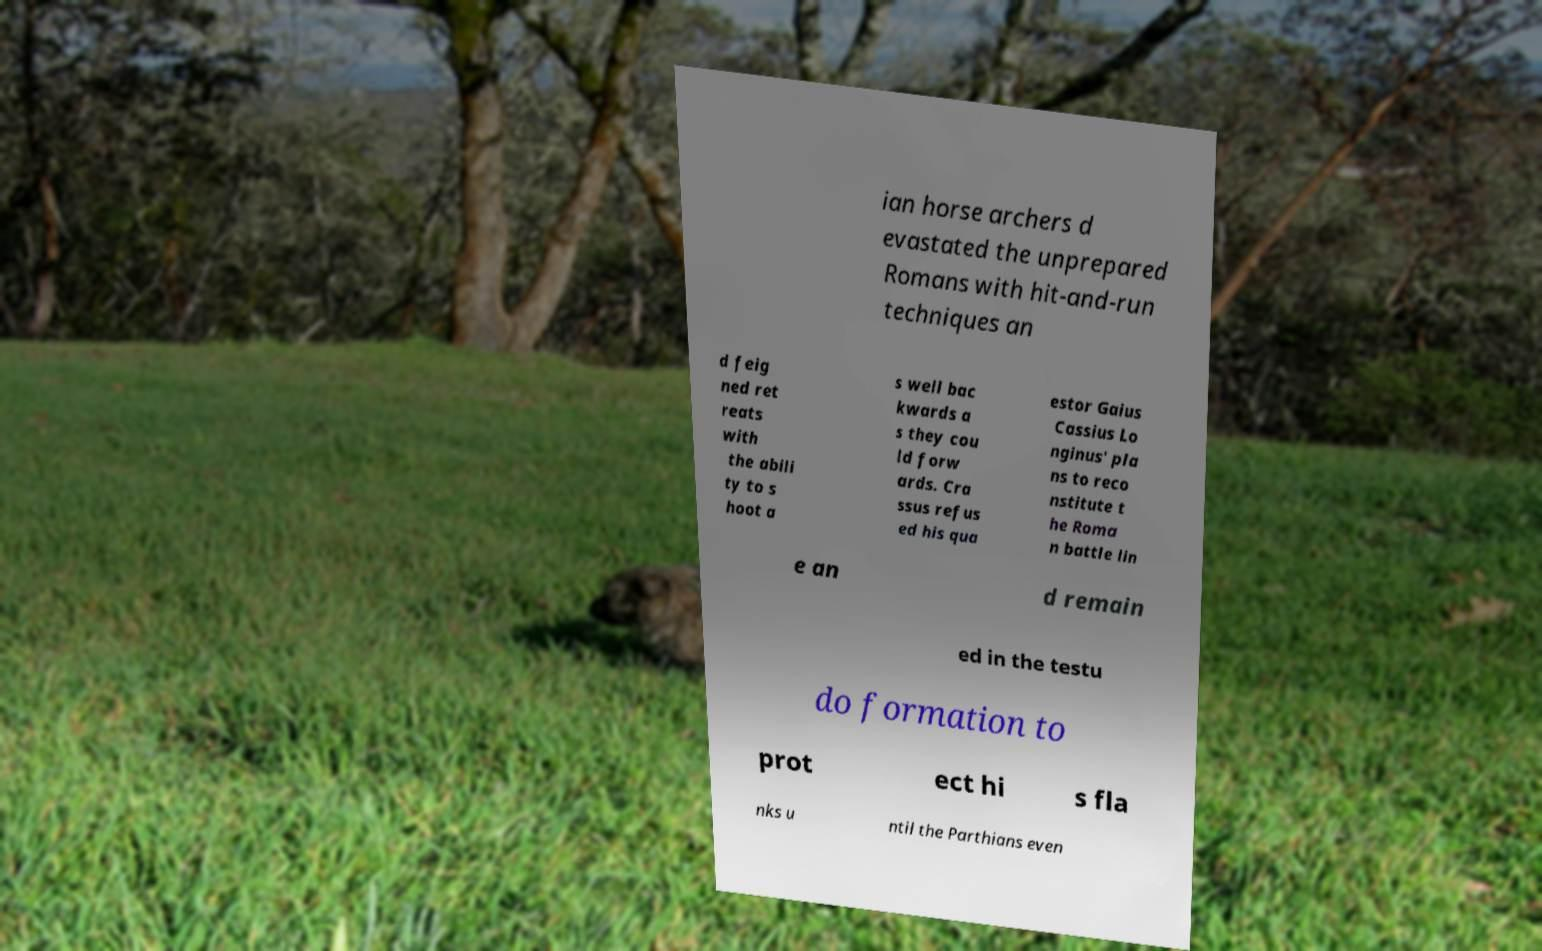There's text embedded in this image that I need extracted. Can you transcribe it verbatim? ian horse archers d evastated the unprepared Romans with hit-and-run techniques an d feig ned ret reats with the abili ty to s hoot a s well bac kwards a s they cou ld forw ards. Cra ssus refus ed his qua estor Gaius Cassius Lo nginus' pla ns to reco nstitute t he Roma n battle lin e an d remain ed in the testu do formation to prot ect hi s fla nks u ntil the Parthians even 